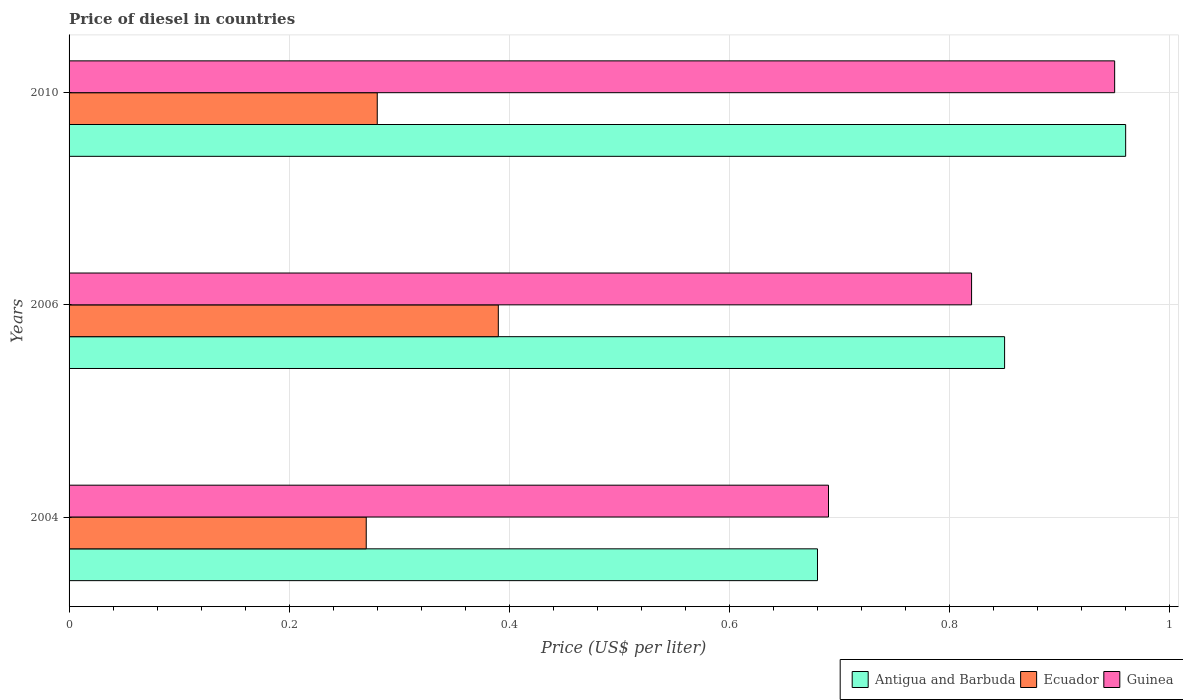How many different coloured bars are there?
Keep it short and to the point. 3. How many groups of bars are there?
Give a very brief answer. 3. Are the number of bars per tick equal to the number of legend labels?
Keep it short and to the point. Yes. How many bars are there on the 1st tick from the top?
Keep it short and to the point. 3. What is the label of the 1st group of bars from the top?
Make the answer very short. 2010. What is the price of diesel in Guinea in 2006?
Your response must be concise. 0.82. Across all years, what is the minimum price of diesel in Antigua and Barbuda?
Offer a very short reply. 0.68. In which year was the price of diesel in Guinea maximum?
Your answer should be very brief. 2010. In which year was the price of diesel in Guinea minimum?
Ensure brevity in your answer.  2004. What is the total price of diesel in Antigua and Barbuda in the graph?
Make the answer very short. 2.49. What is the difference between the price of diesel in Antigua and Barbuda in 2004 and that in 2006?
Give a very brief answer. -0.17. What is the difference between the price of diesel in Antigua and Barbuda in 2010 and the price of diesel in Guinea in 2006?
Your answer should be compact. 0.14. What is the average price of diesel in Ecuador per year?
Keep it short and to the point. 0.31. In the year 2010, what is the difference between the price of diesel in Antigua and Barbuda and price of diesel in Guinea?
Give a very brief answer. 0.01. In how many years, is the price of diesel in Guinea greater than 0.88 US$?
Make the answer very short. 1. What is the ratio of the price of diesel in Ecuador in 2006 to that in 2010?
Give a very brief answer. 1.39. Is the price of diesel in Guinea in 2004 less than that in 2010?
Your answer should be very brief. Yes. Is the difference between the price of diesel in Antigua and Barbuda in 2006 and 2010 greater than the difference between the price of diesel in Guinea in 2006 and 2010?
Keep it short and to the point. Yes. What is the difference between the highest and the second highest price of diesel in Guinea?
Keep it short and to the point. 0.13. What is the difference between the highest and the lowest price of diesel in Ecuador?
Make the answer very short. 0.12. Is the sum of the price of diesel in Antigua and Barbuda in 2006 and 2010 greater than the maximum price of diesel in Guinea across all years?
Your response must be concise. Yes. What does the 1st bar from the top in 2006 represents?
Provide a succinct answer. Guinea. What does the 3rd bar from the bottom in 2004 represents?
Give a very brief answer. Guinea. Is it the case that in every year, the sum of the price of diesel in Antigua and Barbuda and price of diesel in Ecuador is greater than the price of diesel in Guinea?
Your response must be concise. Yes. How many bars are there?
Provide a short and direct response. 9. Are all the bars in the graph horizontal?
Your response must be concise. Yes. How many years are there in the graph?
Ensure brevity in your answer.  3. What is the difference between two consecutive major ticks on the X-axis?
Make the answer very short. 0.2. Are the values on the major ticks of X-axis written in scientific E-notation?
Ensure brevity in your answer.  No. How many legend labels are there?
Keep it short and to the point. 3. How are the legend labels stacked?
Keep it short and to the point. Horizontal. What is the title of the graph?
Make the answer very short. Price of diesel in countries. Does "India" appear as one of the legend labels in the graph?
Your answer should be very brief. No. What is the label or title of the X-axis?
Give a very brief answer. Price (US$ per liter). What is the label or title of the Y-axis?
Make the answer very short. Years. What is the Price (US$ per liter) of Antigua and Barbuda in 2004?
Your answer should be very brief. 0.68. What is the Price (US$ per liter) in Ecuador in 2004?
Offer a terse response. 0.27. What is the Price (US$ per liter) of Guinea in 2004?
Provide a short and direct response. 0.69. What is the Price (US$ per liter) in Ecuador in 2006?
Ensure brevity in your answer.  0.39. What is the Price (US$ per liter) of Guinea in 2006?
Your response must be concise. 0.82. What is the Price (US$ per liter) in Ecuador in 2010?
Provide a short and direct response. 0.28. Across all years, what is the maximum Price (US$ per liter) in Antigua and Barbuda?
Your answer should be compact. 0.96. Across all years, what is the maximum Price (US$ per liter) of Ecuador?
Your answer should be very brief. 0.39. Across all years, what is the minimum Price (US$ per liter) in Antigua and Barbuda?
Offer a very short reply. 0.68. Across all years, what is the minimum Price (US$ per liter) in Ecuador?
Provide a succinct answer. 0.27. Across all years, what is the minimum Price (US$ per liter) of Guinea?
Provide a short and direct response. 0.69. What is the total Price (US$ per liter) of Antigua and Barbuda in the graph?
Your answer should be compact. 2.49. What is the total Price (US$ per liter) of Ecuador in the graph?
Offer a very short reply. 0.94. What is the total Price (US$ per liter) in Guinea in the graph?
Provide a succinct answer. 2.46. What is the difference between the Price (US$ per liter) of Antigua and Barbuda in 2004 and that in 2006?
Offer a terse response. -0.17. What is the difference between the Price (US$ per liter) in Ecuador in 2004 and that in 2006?
Offer a very short reply. -0.12. What is the difference between the Price (US$ per liter) in Guinea in 2004 and that in 2006?
Give a very brief answer. -0.13. What is the difference between the Price (US$ per liter) in Antigua and Barbuda in 2004 and that in 2010?
Your answer should be compact. -0.28. What is the difference between the Price (US$ per liter) of Ecuador in 2004 and that in 2010?
Offer a very short reply. -0.01. What is the difference between the Price (US$ per liter) of Guinea in 2004 and that in 2010?
Give a very brief answer. -0.26. What is the difference between the Price (US$ per liter) of Antigua and Barbuda in 2006 and that in 2010?
Offer a terse response. -0.11. What is the difference between the Price (US$ per liter) of Ecuador in 2006 and that in 2010?
Give a very brief answer. 0.11. What is the difference between the Price (US$ per liter) of Guinea in 2006 and that in 2010?
Provide a short and direct response. -0.13. What is the difference between the Price (US$ per liter) in Antigua and Barbuda in 2004 and the Price (US$ per liter) in Ecuador in 2006?
Provide a short and direct response. 0.29. What is the difference between the Price (US$ per liter) of Antigua and Barbuda in 2004 and the Price (US$ per liter) of Guinea in 2006?
Keep it short and to the point. -0.14. What is the difference between the Price (US$ per liter) of Ecuador in 2004 and the Price (US$ per liter) of Guinea in 2006?
Your answer should be compact. -0.55. What is the difference between the Price (US$ per liter) in Antigua and Barbuda in 2004 and the Price (US$ per liter) in Ecuador in 2010?
Give a very brief answer. 0.4. What is the difference between the Price (US$ per liter) in Antigua and Barbuda in 2004 and the Price (US$ per liter) in Guinea in 2010?
Offer a very short reply. -0.27. What is the difference between the Price (US$ per liter) of Ecuador in 2004 and the Price (US$ per liter) of Guinea in 2010?
Your answer should be very brief. -0.68. What is the difference between the Price (US$ per liter) in Antigua and Barbuda in 2006 and the Price (US$ per liter) in Ecuador in 2010?
Your answer should be compact. 0.57. What is the difference between the Price (US$ per liter) of Ecuador in 2006 and the Price (US$ per liter) of Guinea in 2010?
Your answer should be very brief. -0.56. What is the average Price (US$ per liter) in Antigua and Barbuda per year?
Make the answer very short. 0.83. What is the average Price (US$ per liter) of Ecuador per year?
Your answer should be compact. 0.31. What is the average Price (US$ per liter) of Guinea per year?
Offer a very short reply. 0.82. In the year 2004, what is the difference between the Price (US$ per liter) of Antigua and Barbuda and Price (US$ per liter) of Ecuador?
Your response must be concise. 0.41. In the year 2004, what is the difference between the Price (US$ per liter) of Antigua and Barbuda and Price (US$ per liter) of Guinea?
Keep it short and to the point. -0.01. In the year 2004, what is the difference between the Price (US$ per liter) in Ecuador and Price (US$ per liter) in Guinea?
Keep it short and to the point. -0.42. In the year 2006, what is the difference between the Price (US$ per liter) of Antigua and Barbuda and Price (US$ per liter) of Ecuador?
Ensure brevity in your answer.  0.46. In the year 2006, what is the difference between the Price (US$ per liter) in Ecuador and Price (US$ per liter) in Guinea?
Provide a short and direct response. -0.43. In the year 2010, what is the difference between the Price (US$ per liter) of Antigua and Barbuda and Price (US$ per liter) of Ecuador?
Offer a very short reply. 0.68. In the year 2010, what is the difference between the Price (US$ per liter) of Ecuador and Price (US$ per liter) of Guinea?
Provide a short and direct response. -0.67. What is the ratio of the Price (US$ per liter) in Antigua and Barbuda in 2004 to that in 2006?
Your response must be concise. 0.8. What is the ratio of the Price (US$ per liter) of Ecuador in 2004 to that in 2006?
Offer a terse response. 0.69. What is the ratio of the Price (US$ per liter) in Guinea in 2004 to that in 2006?
Provide a succinct answer. 0.84. What is the ratio of the Price (US$ per liter) in Antigua and Barbuda in 2004 to that in 2010?
Your answer should be very brief. 0.71. What is the ratio of the Price (US$ per liter) in Ecuador in 2004 to that in 2010?
Provide a short and direct response. 0.96. What is the ratio of the Price (US$ per liter) of Guinea in 2004 to that in 2010?
Give a very brief answer. 0.73. What is the ratio of the Price (US$ per liter) in Antigua and Barbuda in 2006 to that in 2010?
Your answer should be compact. 0.89. What is the ratio of the Price (US$ per liter) in Ecuador in 2006 to that in 2010?
Make the answer very short. 1.39. What is the ratio of the Price (US$ per liter) of Guinea in 2006 to that in 2010?
Your response must be concise. 0.86. What is the difference between the highest and the second highest Price (US$ per liter) in Antigua and Barbuda?
Provide a succinct answer. 0.11. What is the difference between the highest and the second highest Price (US$ per liter) of Ecuador?
Make the answer very short. 0.11. What is the difference between the highest and the second highest Price (US$ per liter) of Guinea?
Your response must be concise. 0.13. What is the difference between the highest and the lowest Price (US$ per liter) in Antigua and Barbuda?
Offer a very short reply. 0.28. What is the difference between the highest and the lowest Price (US$ per liter) of Ecuador?
Offer a very short reply. 0.12. What is the difference between the highest and the lowest Price (US$ per liter) in Guinea?
Your answer should be compact. 0.26. 